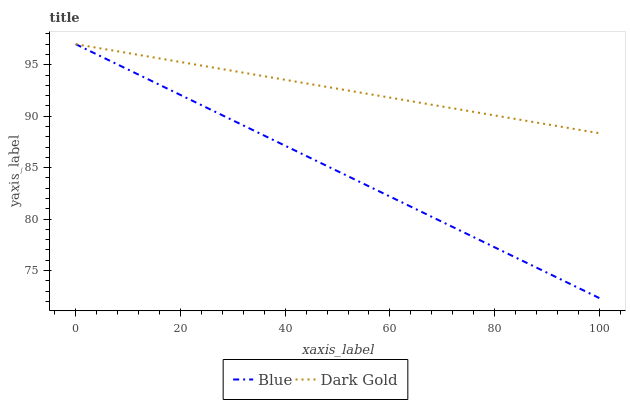Does Blue have the minimum area under the curve?
Answer yes or no. Yes. Does Dark Gold have the maximum area under the curve?
Answer yes or no. Yes. Does Dark Gold have the minimum area under the curve?
Answer yes or no. No. Is Dark Gold the smoothest?
Answer yes or no. Yes. Is Blue the roughest?
Answer yes or no. Yes. Is Dark Gold the roughest?
Answer yes or no. No. Does Dark Gold have the lowest value?
Answer yes or no. No. Does Dark Gold have the highest value?
Answer yes or no. Yes. Does Blue intersect Dark Gold?
Answer yes or no. Yes. Is Blue less than Dark Gold?
Answer yes or no. No. Is Blue greater than Dark Gold?
Answer yes or no. No. 